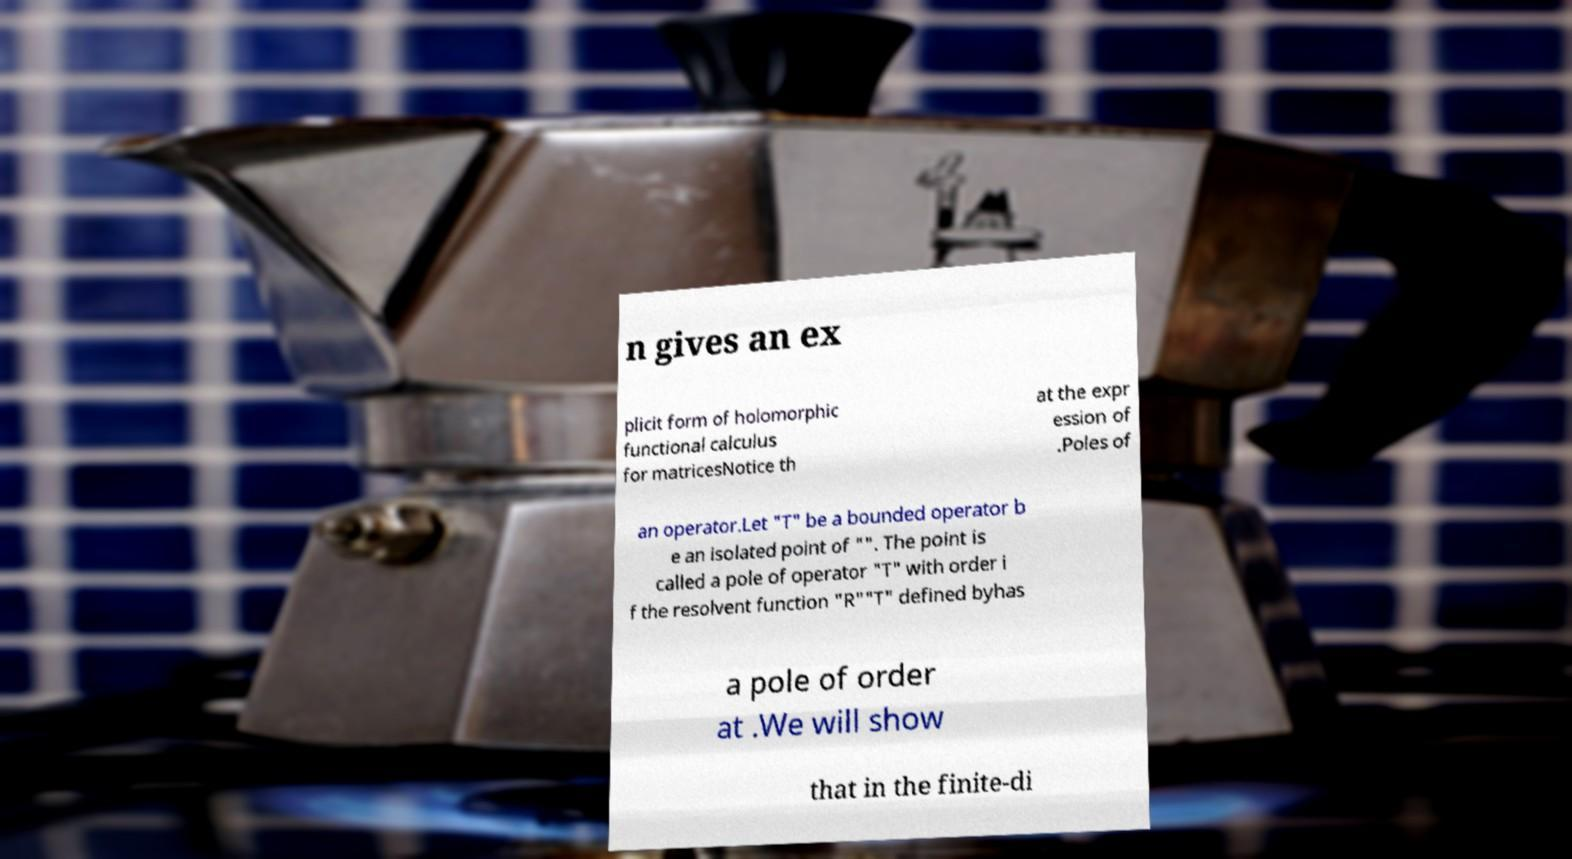For documentation purposes, I need the text within this image transcribed. Could you provide that? n gives an ex plicit form of holomorphic functional calculus for matricesNotice th at the expr ession of .Poles of an operator.Let "T" be a bounded operator b e an isolated point of "". The point is called a pole of operator "T" with order i f the resolvent function "R""T" defined byhas a pole of order at .We will show that in the finite-di 